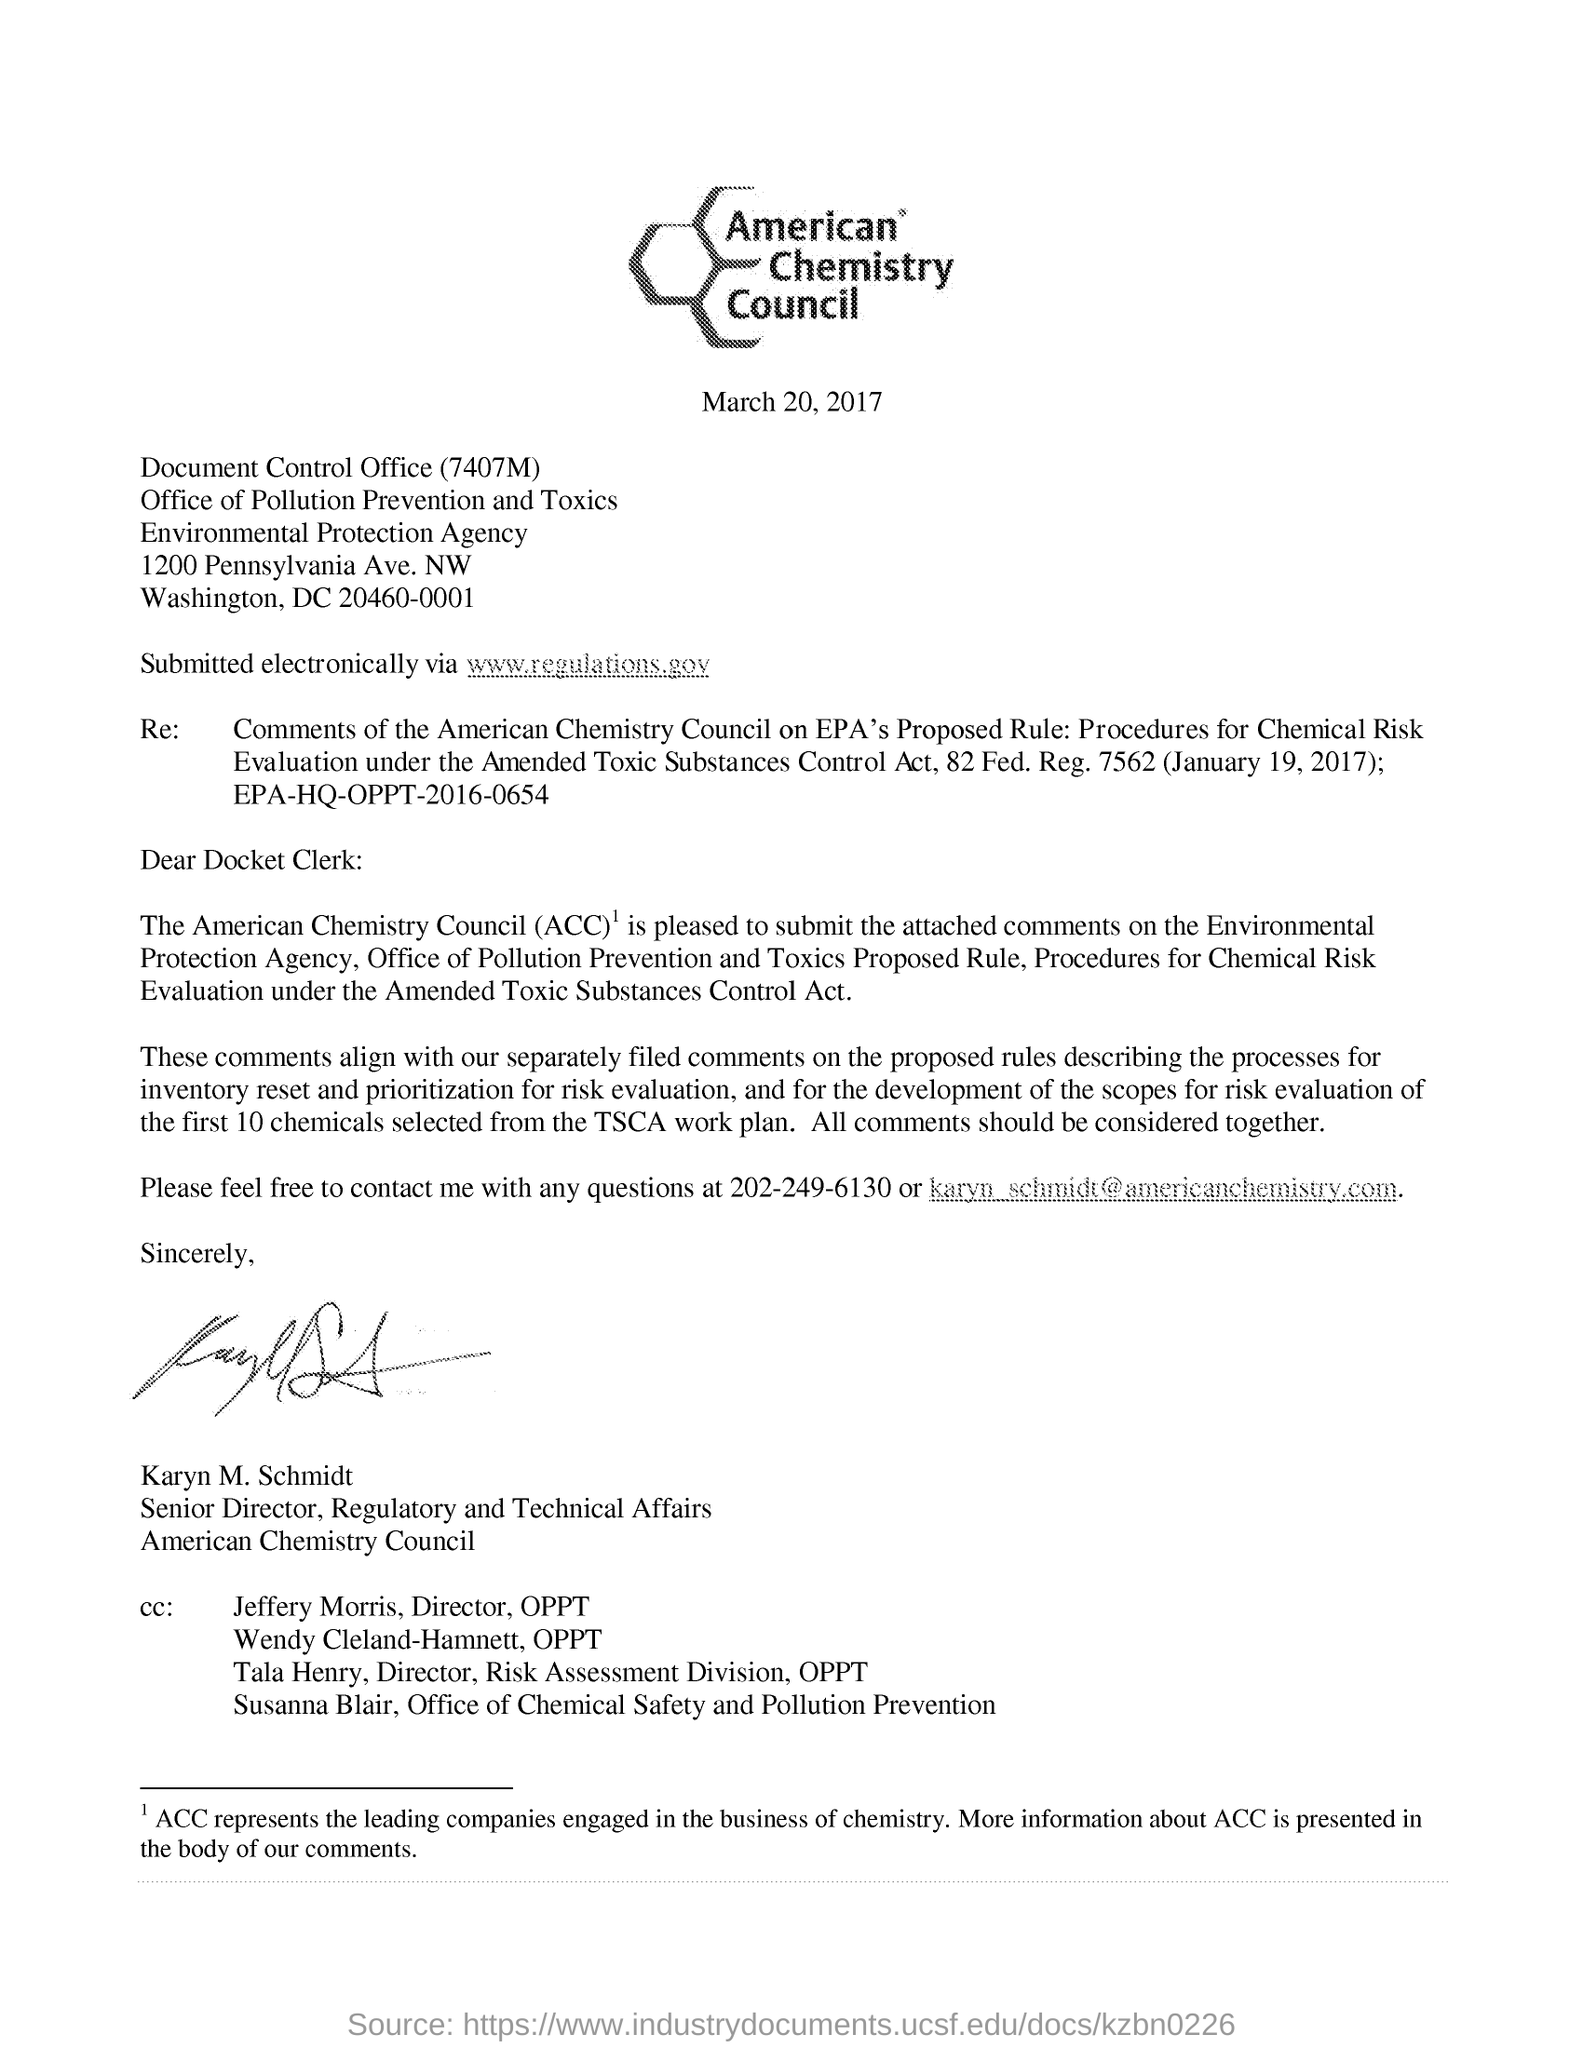Point out several critical features in this image. The American Chemistry Council has a senior director for regulatory and technical affairs named Karyn M. Schmidt. What is the regulatory information for the Amended Toxic Substances Control Act (7562)? The contact number provided in this letter is 202-249-6130. The acronym "ACC" stands for "American Chemistry Council," which is a trade association representing the business of chemistry in the United States. It is necessary to contact Karyn M. Schmidt at number 202-249-6130. 